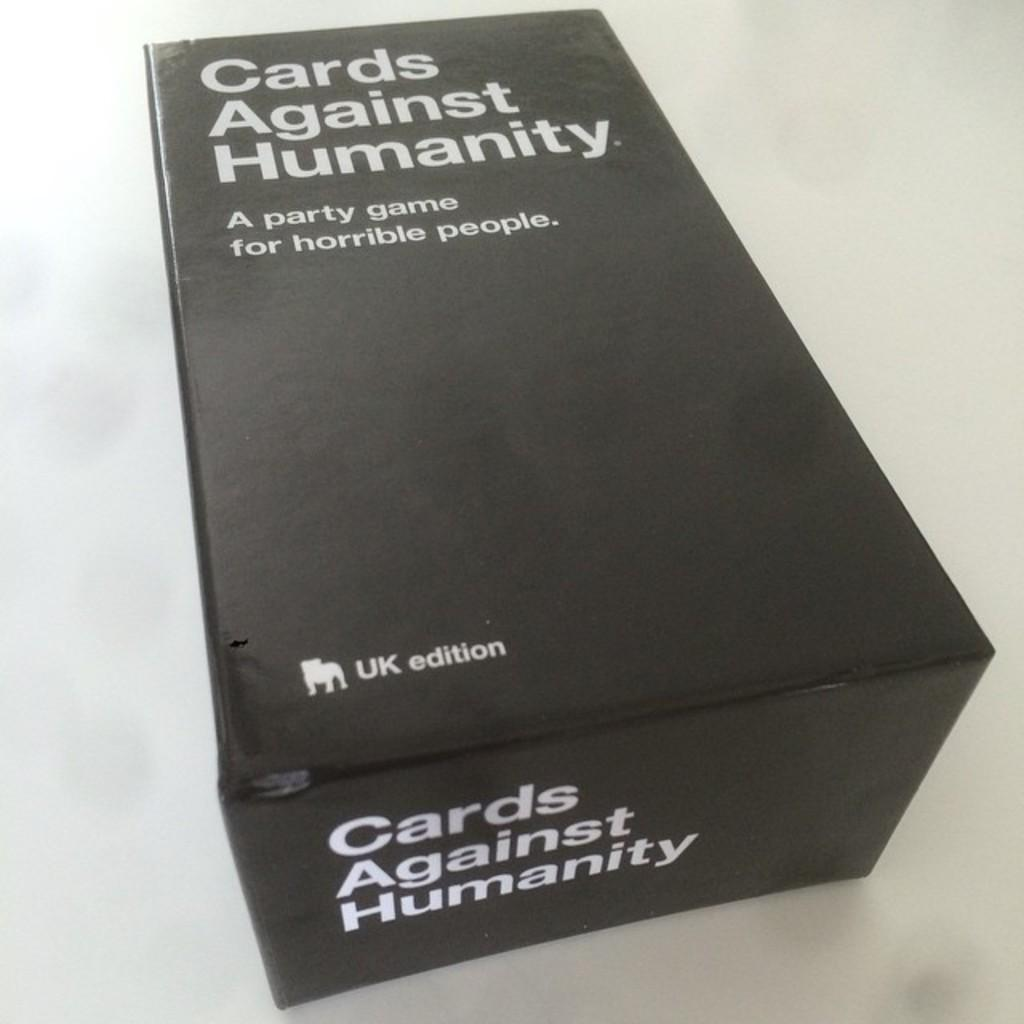<image>
Provide a brief description of the given image. a game box that is labeled as 'cards against humanity' 